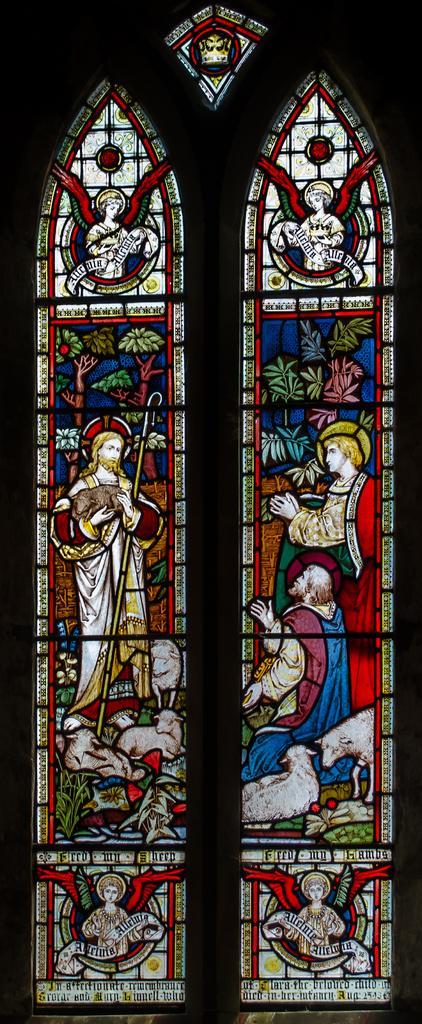In one or two sentences, can you explain what this image depicts? In the image we can see a glass window, on the glass window there are some stickers. 